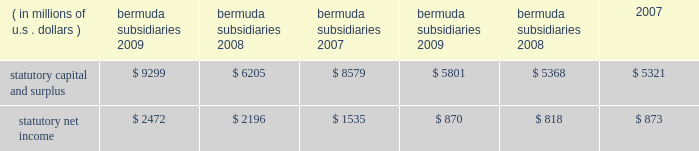N o t e s t o t h e c o n s o l i d a t e d f i n a n c i a l s t a t e m e n t s ( continued ) ace limited and subsidiaries 20 .
Statutory financial information the company 2019s insurance and reinsurance subsidiaries are subject to insurance laws and regulations in the jurisdictions in which they operate .
These regulations include restrictions that limit the amount of dividends or other distributions , such as loans or cash advances , available to shareholders without prior approval of the insurance regulatory authorities .
There are no statutory restrictions on the payment of dividends from retained earnings by any of the bermuda subsidiaries as the minimum statutory capital and surplus requirements are satisfied by the share capital and additional paid-in capital of each of the bermuda subsidiaries .
The company 2019s u.s .
Subsidiaries file financial statements prepared in accordance with statutory accounting practices prescribed or permitted by insurance regulators .
Statutory accounting differs from gaap in the reporting of certain reinsurance contracts , investments , subsidiaries , acquis- ition expenses , fixed assets , deferred income taxes , and certain other items .
The statutory capital and surplus of the u.s .
Subsidiaries met regulatory requirements for 2009 , 2008 , and 2007 .
The amount of dividends available to be paid in 2010 , without prior approval from the state insurance departments , totals $ 733 million .
The combined statutory capital and surplus and statutory net income of the bermuda and u.s .
Subsidiaries as at and for the years ended december 31 , 2009 , 2008 , and 2007 , are as follows: .
As permitted by the restructuring discussed previously in note 7 , certain of the company 2019s u.s .
Subsidiaries discount certain a&e liabilities , which increased statutory capital and surplus by approximately $ 215 million , $ 211 million , and $ 140 million at december 31 , 2009 , 2008 , and 2007 , respectively .
The company 2019s international subsidiaries prepare statutory financial statements based on local laws and regulations .
Some jurisdictions impose complex regulatory requirements on insurance companies while other jurisdictions impose fewer requirements .
In some countries , the company must obtain licenses issued by governmental authorities to conduct local insurance business .
These licenses may be subject to reserves and minimum capital and solvency tests .
Jurisdictions may impose fines , censure , and/or criminal sanctions for violation of regulatory requirements .
21 .
Information provided in connection with outstanding debt of subsidiaries the following tables present condensed consolidating financial information at december 31 , 2009 , and december 31 , 2008 , and for the years ended december 31 , 2009 , 2008 , and 2007 , for ace limited ( the parent guarantor ) and its 201csubsidiary issuer 201d , ace ina holdings , inc .
The subsidiary issuer is an indirect 100 percent-owned subsidiary of the parent guarantor .
Investments in subsidiaries are accounted for by the parent guarantor under the equity method for purposes of the supplemental consolidating presentation .
Earnings of subsidiaries are reflected in the parent guarantor 2019s investment accounts and earnings .
The parent guarantor fully and unconditionally guarantees certain of the debt of the subsidiary issuer. .
What is the growth rate in net income for bermuda subsidiaries from 2008 to 2009? 
Computations: ((2472 - 2196) / 2196)
Answer: 0.12568. 